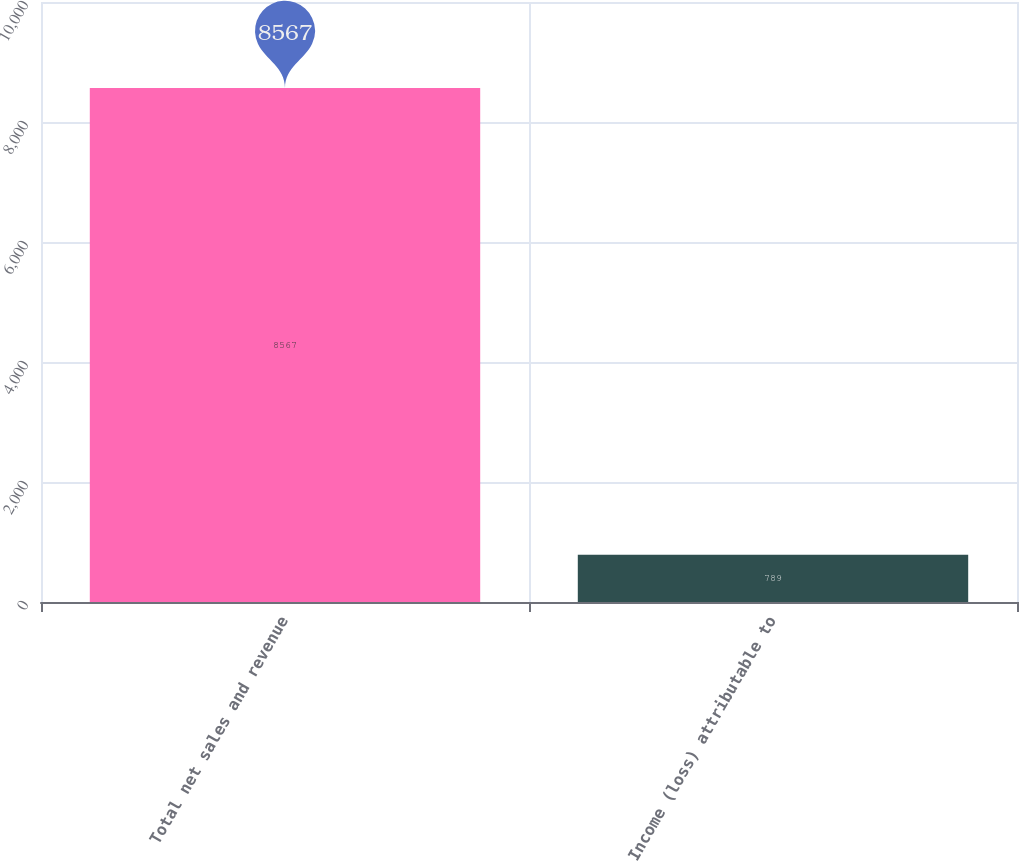Convert chart to OTSL. <chart><loc_0><loc_0><loc_500><loc_500><bar_chart><fcel>Total net sales and revenue<fcel>Income (loss) attributable to<nl><fcel>8567<fcel>789<nl></chart> 